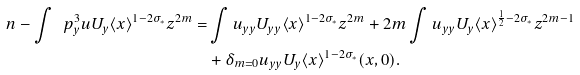<formula> <loc_0><loc_0><loc_500><loc_500>\ n - \int \ p _ { y } ^ { 3 } u U _ { y } \langle x \rangle ^ { 1 - 2 \sigma _ { \ast } } z ^ { 2 m } = & \int u _ { y y } U _ { y y } \langle x \rangle ^ { 1 - 2 \sigma _ { \ast } } z ^ { 2 m } + 2 m \int u _ { y y } U _ { y } \langle x \rangle ^ { \frac { 1 } { 2 } - 2 \sigma _ { \ast } } z ^ { 2 m - 1 } \\ & + \delta _ { m = 0 } u _ { y y } U _ { y } \langle x \rangle ^ { 1 - 2 \sigma _ { \ast } } ( x , 0 ) .</formula> 